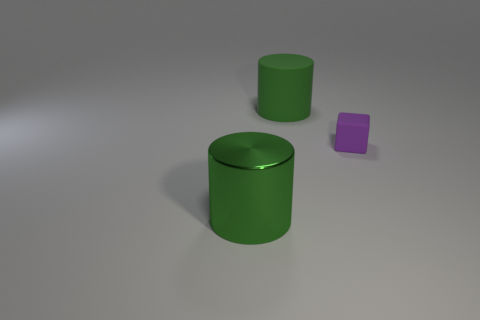What is the size of the rubber object that is the same color as the big metal thing?
Offer a terse response. Large. Is the size of the purple rubber thing the same as the green metallic thing?
Offer a very short reply. No. There is a thing that is both on the left side of the purple cube and in front of the rubber cylinder; what color is it?
Offer a very short reply. Green. What shape is the other large thing that is made of the same material as the purple thing?
Your answer should be very brief. Cylinder. What number of objects are both on the left side of the small purple thing and behind the green metal thing?
Offer a terse response. 1. Is the shape of the object that is on the left side of the large rubber object the same as the big green object behind the large metallic cylinder?
Your answer should be compact. Yes. Does the green cylinder that is in front of the tiny purple matte object have the same material as the purple cube?
Make the answer very short. No. The other thing that is the same shape as the green metallic object is what size?
Offer a terse response. Large. The shiny object is what size?
Your answer should be very brief. Large. Are there more green things behind the big green shiny object than yellow cylinders?
Your answer should be compact. Yes. 